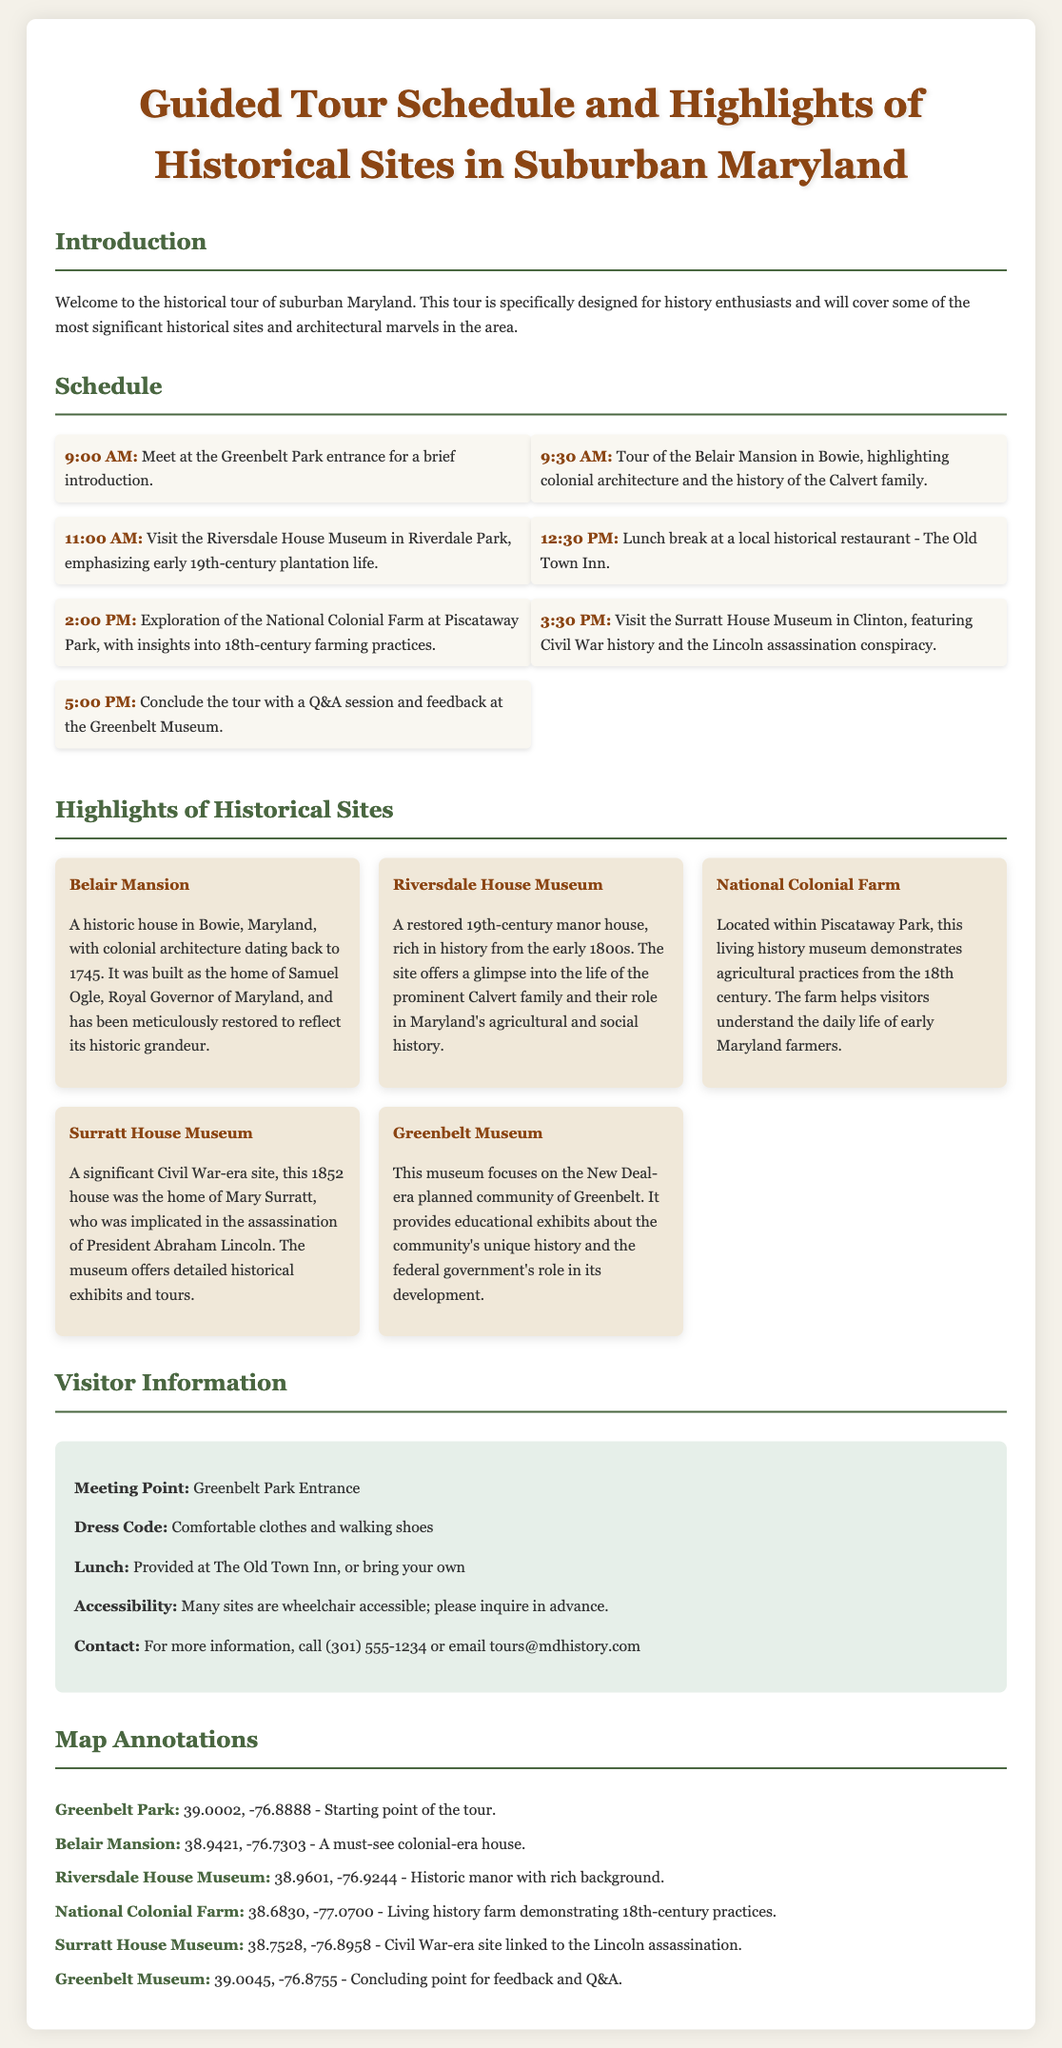what time does the tour start? The tour starts at 9:00 AM at the Greenbelt Park entrance.
Answer: 9:00 AM how many highlights of historical sites are mentioned? There are five highlights of historical sites listed in the document.
Answer: 5 which museum focuses on Civil War history? The document specifies the Surratt House Museum as the one featuring Civil War history.
Answer: Surratt House Museum what is the contact phone number for more information? The contact phone number provided in the document is (301) 555-1234.
Answer: (301) 555-1234 what is the meeting point for the tour? The meeting point is the Greenbelt Park Entrance according to the visitor information section.
Answer: Greenbelt Park Entrance which restaurant is mentioned for lunch? The Old Town Inn is mentioned as the location for lunch during the tour.
Answer: The Old Town Inn what type of architecture is highlighted at Belair Mansion? The document notes colonial architecture as the type highlighted at Belair Mansion.
Answer: colonial architecture what is the significance of the National Colonial Farm? The National Colonial Farm demonstrates 18th-century farming practices according to its highlight description.
Answer: 18th-century farming practices 